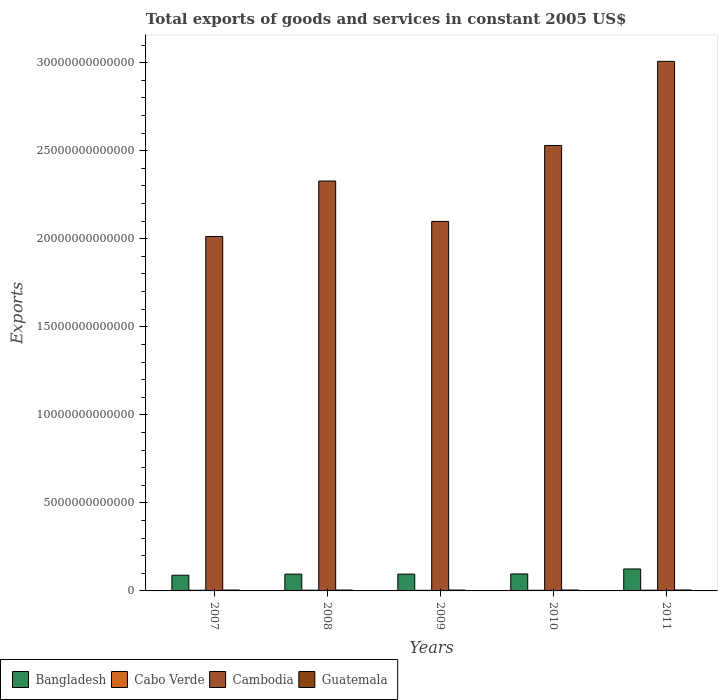How many different coloured bars are there?
Provide a short and direct response. 4. Are the number of bars on each tick of the X-axis equal?
Keep it short and to the point. Yes. How many bars are there on the 4th tick from the left?
Your response must be concise. 4. How many bars are there on the 1st tick from the right?
Offer a terse response. 4. What is the total exports of goods and services in Cambodia in 2007?
Ensure brevity in your answer.  2.01e+13. Across all years, what is the maximum total exports of goods and services in Cabo Verde?
Ensure brevity in your answer.  4.15e+1. Across all years, what is the minimum total exports of goods and services in Guatemala?
Give a very brief answer. 4.90e+1. What is the total total exports of goods and services in Cambodia in the graph?
Give a very brief answer. 1.20e+14. What is the difference between the total exports of goods and services in Bangladesh in 2007 and that in 2011?
Provide a short and direct response. -3.55e+11. What is the difference between the total exports of goods and services in Bangladesh in 2007 and the total exports of goods and services in Cabo Verde in 2009?
Provide a short and direct response. 8.57e+11. What is the average total exports of goods and services in Bangladesh per year?
Ensure brevity in your answer.  1.00e+12. In the year 2008, what is the difference between the total exports of goods and services in Guatemala and total exports of goods and services in Bangladesh?
Keep it short and to the point. -9.04e+11. In how many years, is the total exports of goods and services in Bangladesh greater than 19000000000000 US$?
Provide a short and direct response. 0. What is the ratio of the total exports of goods and services in Bangladesh in 2008 to that in 2009?
Your answer should be very brief. 1. Is the difference between the total exports of goods and services in Guatemala in 2008 and 2011 greater than the difference between the total exports of goods and services in Bangladesh in 2008 and 2011?
Provide a succinct answer. Yes. What is the difference between the highest and the second highest total exports of goods and services in Cambodia?
Offer a terse response. 4.78e+12. What is the difference between the highest and the lowest total exports of goods and services in Cambodia?
Provide a short and direct response. 9.95e+12. In how many years, is the total exports of goods and services in Cambodia greater than the average total exports of goods and services in Cambodia taken over all years?
Ensure brevity in your answer.  2. What does the 1st bar from the right in 2009 represents?
Your response must be concise. Guatemala. How many bars are there?
Provide a short and direct response. 20. What is the difference between two consecutive major ticks on the Y-axis?
Offer a very short reply. 5.00e+12. Are the values on the major ticks of Y-axis written in scientific E-notation?
Keep it short and to the point. No. Does the graph contain any zero values?
Your answer should be very brief. No. Does the graph contain grids?
Provide a succinct answer. No. Where does the legend appear in the graph?
Provide a short and direct response. Bottom left. How many legend labels are there?
Your answer should be compact. 4. What is the title of the graph?
Your response must be concise. Total exports of goods and services in constant 2005 US$. Does "Finland" appear as one of the legend labels in the graph?
Make the answer very short. No. What is the label or title of the Y-axis?
Ensure brevity in your answer.  Exports. What is the Exports of Bangladesh in 2007?
Your response must be concise. 8.91e+11. What is the Exports of Cabo Verde in 2007?
Keep it short and to the point. 3.85e+1. What is the Exports in Cambodia in 2007?
Offer a terse response. 2.01e+13. What is the Exports in Guatemala in 2007?
Make the answer very short. 5.05e+1. What is the Exports of Bangladesh in 2008?
Your answer should be compact. 9.54e+11. What is the Exports of Cabo Verde in 2008?
Your response must be concise. 4.13e+1. What is the Exports in Cambodia in 2008?
Offer a terse response. 2.33e+13. What is the Exports of Guatemala in 2008?
Provide a short and direct response. 5.04e+1. What is the Exports in Bangladesh in 2009?
Offer a very short reply. 9.55e+11. What is the Exports of Cabo Verde in 2009?
Your answer should be compact. 3.41e+1. What is the Exports in Cambodia in 2009?
Your answer should be compact. 2.10e+13. What is the Exports in Guatemala in 2009?
Keep it short and to the point. 4.90e+1. What is the Exports of Bangladesh in 2010?
Provide a succinct answer. 9.63e+11. What is the Exports in Cabo Verde in 2010?
Your response must be concise. 3.73e+1. What is the Exports in Cambodia in 2010?
Ensure brevity in your answer.  2.53e+13. What is the Exports of Guatemala in 2010?
Give a very brief answer. 5.20e+1. What is the Exports in Bangladesh in 2011?
Give a very brief answer. 1.25e+12. What is the Exports of Cabo Verde in 2011?
Offer a terse response. 4.15e+1. What is the Exports in Cambodia in 2011?
Your response must be concise. 3.01e+13. What is the Exports in Guatemala in 2011?
Your answer should be very brief. 5.36e+1. Across all years, what is the maximum Exports of Bangladesh?
Keep it short and to the point. 1.25e+12. Across all years, what is the maximum Exports in Cabo Verde?
Provide a short and direct response. 4.15e+1. Across all years, what is the maximum Exports in Cambodia?
Offer a very short reply. 3.01e+13. Across all years, what is the maximum Exports in Guatemala?
Provide a short and direct response. 5.36e+1. Across all years, what is the minimum Exports of Bangladesh?
Your answer should be very brief. 8.91e+11. Across all years, what is the minimum Exports of Cabo Verde?
Your response must be concise. 3.41e+1. Across all years, what is the minimum Exports in Cambodia?
Offer a very short reply. 2.01e+13. Across all years, what is the minimum Exports of Guatemala?
Make the answer very short. 4.90e+1. What is the total Exports in Bangladesh in the graph?
Ensure brevity in your answer.  5.01e+12. What is the total Exports in Cabo Verde in the graph?
Your answer should be compact. 1.93e+11. What is the total Exports in Cambodia in the graph?
Offer a terse response. 1.20e+14. What is the total Exports in Guatemala in the graph?
Your answer should be very brief. 2.55e+11. What is the difference between the Exports in Bangladesh in 2007 and that in 2008?
Keep it short and to the point. -6.31e+1. What is the difference between the Exports of Cabo Verde in 2007 and that in 2008?
Your answer should be very brief. -2.83e+09. What is the difference between the Exports of Cambodia in 2007 and that in 2008?
Your answer should be compact. -3.15e+12. What is the difference between the Exports in Guatemala in 2007 and that in 2008?
Offer a very short reply. 8.22e+07. What is the difference between the Exports of Bangladesh in 2007 and that in 2009?
Your response must be concise. -6.34e+1. What is the difference between the Exports in Cabo Verde in 2007 and that in 2009?
Your answer should be very brief. 4.38e+09. What is the difference between the Exports in Cambodia in 2007 and that in 2009?
Provide a succinct answer. -8.55e+11. What is the difference between the Exports in Guatemala in 2007 and that in 2009?
Provide a short and direct response. 1.42e+09. What is the difference between the Exports in Bangladesh in 2007 and that in 2010?
Offer a very short reply. -7.24e+1. What is the difference between the Exports of Cabo Verde in 2007 and that in 2010?
Your answer should be very brief. 1.20e+09. What is the difference between the Exports of Cambodia in 2007 and that in 2010?
Your answer should be compact. -5.17e+12. What is the difference between the Exports in Guatemala in 2007 and that in 2010?
Provide a short and direct response. -1.58e+09. What is the difference between the Exports of Bangladesh in 2007 and that in 2011?
Ensure brevity in your answer.  -3.55e+11. What is the difference between the Exports of Cabo Verde in 2007 and that in 2011?
Your answer should be very brief. -3.00e+09. What is the difference between the Exports in Cambodia in 2007 and that in 2011?
Keep it short and to the point. -9.95e+12. What is the difference between the Exports in Guatemala in 2007 and that in 2011?
Give a very brief answer. -3.15e+09. What is the difference between the Exports in Bangladesh in 2008 and that in 2009?
Ensure brevity in your answer.  -2.72e+08. What is the difference between the Exports in Cabo Verde in 2008 and that in 2009?
Your answer should be compact. 7.21e+09. What is the difference between the Exports in Cambodia in 2008 and that in 2009?
Offer a terse response. 2.30e+12. What is the difference between the Exports in Guatemala in 2008 and that in 2009?
Your answer should be very brief. 1.34e+09. What is the difference between the Exports of Bangladesh in 2008 and that in 2010?
Provide a short and direct response. -9.26e+09. What is the difference between the Exports in Cabo Verde in 2008 and that in 2010?
Give a very brief answer. 4.03e+09. What is the difference between the Exports in Cambodia in 2008 and that in 2010?
Keep it short and to the point. -2.02e+12. What is the difference between the Exports of Guatemala in 2008 and that in 2010?
Provide a short and direct response. -1.67e+09. What is the difference between the Exports of Bangladesh in 2008 and that in 2011?
Your answer should be very brief. -2.92e+11. What is the difference between the Exports of Cabo Verde in 2008 and that in 2011?
Your answer should be very brief. -1.64e+08. What is the difference between the Exports of Cambodia in 2008 and that in 2011?
Offer a terse response. -6.80e+12. What is the difference between the Exports of Guatemala in 2008 and that in 2011?
Offer a very short reply. -3.23e+09. What is the difference between the Exports in Bangladesh in 2009 and that in 2010?
Make the answer very short. -8.99e+09. What is the difference between the Exports of Cabo Verde in 2009 and that in 2010?
Provide a succinct answer. -3.18e+09. What is the difference between the Exports of Cambodia in 2009 and that in 2010?
Offer a very short reply. -4.31e+12. What is the difference between the Exports of Guatemala in 2009 and that in 2010?
Offer a very short reply. -3.01e+09. What is the difference between the Exports in Bangladesh in 2009 and that in 2011?
Your response must be concise. -2.92e+11. What is the difference between the Exports of Cabo Verde in 2009 and that in 2011?
Provide a short and direct response. -7.37e+09. What is the difference between the Exports of Cambodia in 2009 and that in 2011?
Provide a short and direct response. -9.09e+12. What is the difference between the Exports of Guatemala in 2009 and that in 2011?
Your response must be concise. -4.57e+09. What is the difference between the Exports of Bangladesh in 2010 and that in 2011?
Ensure brevity in your answer.  -2.83e+11. What is the difference between the Exports in Cabo Verde in 2010 and that in 2011?
Provide a succinct answer. -4.19e+09. What is the difference between the Exports in Cambodia in 2010 and that in 2011?
Give a very brief answer. -4.78e+12. What is the difference between the Exports of Guatemala in 2010 and that in 2011?
Ensure brevity in your answer.  -1.57e+09. What is the difference between the Exports in Bangladesh in 2007 and the Exports in Cabo Verde in 2008?
Your answer should be compact. 8.50e+11. What is the difference between the Exports of Bangladesh in 2007 and the Exports of Cambodia in 2008?
Offer a very short reply. -2.24e+13. What is the difference between the Exports in Bangladesh in 2007 and the Exports in Guatemala in 2008?
Your answer should be compact. 8.41e+11. What is the difference between the Exports in Cabo Verde in 2007 and the Exports in Cambodia in 2008?
Make the answer very short. -2.32e+13. What is the difference between the Exports of Cabo Verde in 2007 and the Exports of Guatemala in 2008?
Keep it short and to the point. -1.19e+1. What is the difference between the Exports of Cambodia in 2007 and the Exports of Guatemala in 2008?
Give a very brief answer. 2.01e+13. What is the difference between the Exports in Bangladesh in 2007 and the Exports in Cabo Verde in 2009?
Ensure brevity in your answer.  8.57e+11. What is the difference between the Exports in Bangladesh in 2007 and the Exports in Cambodia in 2009?
Your answer should be compact. -2.01e+13. What is the difference between the Exports in Bangladesh in 2007 and the Exports in Guatemala in 2009?
Give a very brief answer. 8.42e+11. What is the difference between the Exports in Cabo Verde in 2007 and the Exports in Cambodia in 2009?
Offer a terse response. -2.09e+13. What is the difference between the Exports of Cabo Verde in 2007 and the Exports of Guatemala in 2009?
Provide a short and direct response. -1.06e+1. What is the difference between the Exports in Cambodia in 2007 and the Exports in Guatemala in 2009?
Your answer should be very brief. 2.01e+13. What is the difference between the Exports of Bangladesh in 2007 and the Exports of Cabo Verde in 2010?
Offer a terse response. 8.54e+11. What is the difference between the Exports in Bangladesh in 2007 and the Exports in Cambodia in 2010?
Provide a succinct answer. -2.44e+13. What is the difference between the Exports in Bangladesh in 2007 and the Exports in Guatemala in 2010?
Make the answer very short. 8.39e+11. What is the difference between the Exports in Cabo Verde in 2007 and the Exports in Cambodia in 2010?
Your response must be concise. -2.53e+13. What is the difference between the Exports in Cabo Verde in 2007 and the Exports in Guatemala in 2010?
Provide a short and direct response. -1.36e+1. What is the difference between the Exports in Cambodia in 2007 and the Exports in Guatemala in 2010?
Your answer should be very brief. 2.01e+13. What is the difference between the Exports in Bangladesh in 2007 and the Exports in Cabo Verde in 2011?
Offer a very short reply. 8.50e+11. What is the difference between the Exports in Bangladesh in 2007 and the Exports in Cambodia in 2011?
Your answer should be compact. -2.92e+13. What is the difference between the Exports in Bangladesh in 2007 and the Exports in Guatemala in 2011?
Provide a succinct answer. 8.38e+11. What is the difference between the Exports of Cabo Verde in 2007 and the Exports of Cambodia in 2011?
Give a very brief answer. -3.00e+13. What is the difference between the Exports of Cabo Verde in 2007 and the Exports of Guatemala in 2011?
Your answer should be very brief. -1.51e+1. What is the difference between the Exports in Cambodia in 2007 and the Exports in Guatemala in 2011?
Make the answer very short. 2.01e+13. What is the difference between the Exports of Bangladesh in 2008 and the Exports of Cabo Verde in 2009?
Ensure brevity in your answer.  9.20e+11. What is the difference between the Exports in Bangladesh in 2008 and the Exports in Cambodia in 2009?
Make the answer very short. -2.00e+13. What is the difference between the Exports of Bangladesh in 2008 and the Exports of Guatemala in 2009?
Make the answer very short. 9.05e+11. What is the difference between the Exports of Cabo Verde in 2008 and the Exports of Cambodia in 2009?
Ensure brevity in your answer.  -2.09e+13. What is the difference between the Exports of Cabo Verde in 2008 and the Exports of Guatemala in 2009?
Make the answer very short. -7.73e+09. What is the difference between the Exports in Cambodia in 2008 and the Exports in Guatemala in 2009?
Provide a short and direct response. 2.32e+13. What is the difference between the Exports in Bangladesh in 2008 and the Exports in Cabo Verde in 2010?
Offer a very short reply. 9.17e+11. What is the difference between the Exports in Bangladesh in 2008 and the Exports in Cambodia in 2010?
Your answer should be very brief. -2.43e+13. What is the difference between the Exports in Bangladesh in 2008 and the Exports in Guatemala in 2010?
Provide a succinct answer. 9.02e+11. What is the difference between the Exports in Cabo Verde in 2008 and the Exports in Cambodia in 2010?
Keep it short and to the point. -2.53e+13. What is the difference between the Exports of Cabo Verde in 2008 and the Exports of Guatemala in 2010?
Provide a short and direct response. -1.07e+1. What is the difference between the Exports of Cambodia in 2008 and the Exports of Guatemala in 2010?
Provide a short and direct response. 2.32e+13. What is the difference between the Exports in Bangladesh in 2008 and the Exports in Cabo Verde in 2011?
Provide a short and direct response. 9.13e+11. What is the difference between the Exports of Bangladesh in 2008 and the Exports of Cambodia in 2011?
Offer a very short reply. -2.91e+13. What is the difference between the Exports of Bangladesh in 2008 and the Exports of Guatemala in 2011?
Provide a short and direct response. 9.01e+11. What is the difference between the Exports of Cabo Verde in 2008 and the Exports of Cambodia in 2011?
Your answer should be compact. -3.00e+13. What is the difference between the Exports of Cabo Verde in 2008 and the Exports of Guatemala in 2011?
Your answer should be very brief. -1.23e+1. What is the difference between the Exports in Cambodia in 2008 and the Exports in Guatemala in 2011?
Make the answer very short. 2.32e+13. What is the difference between the Exports of Bangladesh in 2009 and the Exports of Cabo Verde in 2010?
Your response must be concise. 9.17e+11. What is the difference between the Exports in Bangladesh in 2009 and the Exports in Cambodia in 2010?
Your answer should be compact. -2.43e+13. What is the difference between the Exports of Bangladesh in 2009 and the Exports of Guatemala in 2010?
Offer a terse response. 9.02e+11. What is the difference between the Exports in Cabo Verde in 2009 and the Exports in Cambodia in 2010?
Offer a very short reply. -2.53e+13. What is the difference between the Exports in Cabo Verde in 2009 and the Exports in Guatemala in 2010?
Your answer should be compact. -1.79e+1. What is the difference between the Exports of Cambodia in 2009 and the Exports of Guatemala in 2010?
Provide a short and direct response. 2.09e+13. What is the difference between the Exports of Bangladesh in 2009 and the Exports of Cabo Verde in 2011?
Ensure brevity in your answer.  9.13e+11. What is the difference between the Exports in Bangladesh in 2009 and the Exports in Cambodia in 2011?
Give a very brief answer. -2.91e+13. What is the difference between the Exports of Bangladesh in 2009 and the Exports of Guatemala in 2011?
Keep it short and to the point. 9.01e+11. What is the difference between the Exports of Cabo Verde in 2009 and the Exports of Cambodia in 2011?
Your answer should be compact. -3.00e+13. What is the difference between the Exports of Cabo Verde in 2009 and the Exports of Guatemala in 2011?
Provide a succinct answer. -1.95e+1. What is the difference between the Exports of Cambodia in 2009 and the Exports of Guatemala in 2011?
Your answer should be very brief. 2.09e+13. What is the difference between the Exports in Bangladesh in 2010 and the Exports in Cabo Verde in 2011?
Make the answer very short. 9.22e+11. What is the difference between the Exports in Bangladesh in 2010 and the Exports in Cambodia in 2011?
Give a very brief answer. -2.91e+13. What is the difference between the Exports in Bangladesh in 2010 and the Exports in Guatemala in 2011?
Your answer should be compact. 9.10e+11. What is the difference between the Exports of Cabo Verde in 2010 and the Exports of Cambodia in 2011?
Ensure brevity in your answer.  -3.00e+13. What is the difference between the Exports of Cabo Verde in 2010 and the Exports of Guatemala in 2011?
Offer a very short reply. -1.63e+1. What is the difference between the Exports in Cambodia in 2010 and the Exports in Guatemala in 2011?
Your answer should be very brief. 2.52e+13. What is the average Exports of Bangladesh per year?
Provide a short and direct response. 1.00e+12. What is the average Exports in Cabo Verde per year?
Make the answer very short. 3.85e+1. What is the average Exports of Cambodia per year?
Make the answer very short. 2.40e+13. What is the average Exports in Guatemala per year?
Offer a very short reply. 5.11e+1. In the year 2007, what is the difference between the Exports of Bangladesh and Exports of Cabo Verde?
Keep it short and to the point. 8.53e+11. In the year 2007, what is the difference between the Exports of Bangladesh and Exports of Cambodia?
Your answer should be compact. -1.92e+13. In the year 2007, what is the difference between the Exports in Bangladesh and Exports in Guatemala?
Your answer should be compact. 8.41e+11. In the year 2007, what is the difference between the Exports in Cabo Verde and Exports in Cambodia?
Make the answer very short. -2.01e+13. In the year 2007, what is the difference between the Exports in Cabo Verde and Exports in Guatemala?
Give a very brief answer. -1.20e+1. In the year 2007, what is the difference between the Exports in Cambodia and Exports in Guatemala?
Give a very brief answer. 2.01e+13. In the year 2008, what is the difference between the Exports in Bangladesh and Exports in Cabo Verde?
Offer a very short reply. 9.13e+11. In the year 2008, what is the difference between the Exports of Bangladesh and Exports of Cambodia?
Make the answer very short. -2.23e+13. In the year 2008, what is the difference between the Exports of Bangladesh and Exports of Guatemala?
Ensure brevity in your answer.  9.04e+11. In the year 2008, what is the difference between the Exports in Cabo Verde and Exports in Cambodia?
Make the answer very short. -2.32e+13. In the year 2008, what is the difference between the Exports of Cabo Verde and Exports of Guatemala?
Make the answer very short. -9.07e+09. In the year 2008, what is the difference between the Exports in Cambodia and Exports in Guatemala?
Offer a very short reply. 2.32e+13. In the year 2009, what is the difference between the Exports of Bangladesh and Exports of Cabo Verde?
Offer a terse response. 9.20e+11. In the year 2009, what is the difference between the Exports of Bangladesh and Exports of Cambodia?
Offer a terse response. -2.00e+13. In the year 2009, what is the difference between the Exports in Bangladesh and Exports in Guatemala?
Ensure brevity in your answer.  9.05e+11. In the year 2009, what is the difference between the Exports in Cabo Verde and Exports in Cambodia?
Offer a very short reply. -2.09e+13. In the year 2009, what is the difference between the Exports of Cabo Verde and Exports of Guatemala?
Your answer should be compact. -1.49e+1. In the year 2009, what is the difference between the Exports in Cambodia and Exports in Guatemala?
Keep it short and to the point. 2.09e+13. In the year 2010, what is the difference between the Exports of Bangladesh and Exports of Cabo Verde?
Give a very brief answer. 9.26e+11. In the year 2010, what is the difference between the Exports in Bangladesh and Exports in Cambodia?
Provide a succinct answer. -2.43e+13. In the year 2010, what is the difference between the Exports in Bangladesh and Exports in Guatemala?
Give a very brief answer. 9.11e+11. In the year 2010, what is the difference between the Exports of Cabo Verde and Exports of Cambodia?
Keep it short and to the point. -2.53e+13. In the year 2010, what is the difference between the Exports of Cabo Verde and Exports of Guatemala?
Offer a very short reply. -1.48e+1. In the year 2010, what is the difference between the Exports in Cambodia and Exports in Guatemala?
Keep it short and to the point. 2.52e+13. In the year 2011, what is the difference between the Exports of Bangladesh and Exports of Cabo Verde?
Offer a very short reply. 1.20e+12. In the year 2011, what is the difference between the Exports of Bangladesh and Exports of Cambodia?
Make the answer very short. -2.88e+13. In the year 2011, what is the difference between the Exports of Bangladesh and Exports of Guatemala?
Keep it short and to the point. 1.19e+12. In the year 2011, what is the difference between the Exports of Cabo Verde and Exports of Cambodia?
Give a very brief answer. -3.00e+13. In the year 2011, what is the difference between the Exports in Cabo Verde and Exports in Guatemala?
Offer a terse response. -1.21e+1. In the year 2011, what is the difference between the Exports in Cambodia and Exports in Guatemala?
Your response must be concise. 3.00e+13. What is the ratio of the Exports in Bangladesh in 2007 to that in 2008?
Provide a succinct answer. 0.93. What is the ratio of the Exports of Cabo Verde in 2007 to that in 2008?
Keep it short and to the point. 0.93. What is the ratio of the Exports in Cambodia in 2007 to that in 2008?
Keep it short and to the point. 0.86. What is the ratio of the Exports of Bangladesh in 2007 to that in 2009?
Make the answer very short. 0.93. What is the ratio of the Exports of Cabo Verde in 2007 to that in 2009?
Provide a short and direct response. 1.13. What is the ratio of the Exports in Cambodia in 2007 to that in 2009?
Your answer should be compact. 0.96. What is the ratio of the Exports of Bangladesh in 2007 to that in 2010?
Give a very brief answer. 0.92. What is the ratio of the Exports in Cabo Verde in 2007 to that in 2010?
Offer a very short reply. 1.03. What is the ratio of the Exports in Cambodia in 2007 to that in 2010?
Make the answer very short. 0.8. What is the ratio of the Exports in Guatemala in 2007 to that in 2010?
Make the answer very short. 0.97. What is the ratio of the Exports in Bangladesh in 2007 to that in 2011?
Keep it short and to the point. 0.72. What is the ratio of the Exports in Cabo Verde in 2007 to that in 2011?
Make the answer very short. 0.93. What is the ratio of the Exports of Cambodia in 2007 to that in 2011?
Provide a succinct answer. 0.67. What is the ratio of the Exports in Bangladesh in 2008 to that in 2009?
Ensure brevity in your answer.  1. What is the ratio of the Exports in Cabo Verde in 2008 to that in 2009?
Your response must be concise. 1.21. What is the ratio of the Exports in Cambodia in 2008 to that in 2009?
Your answer should be compact. 1.11. What is the ratio of the Exports of Guatemala in 2008 to that in 2009?
Your response must be concise. 1.03. What is the ratio of the Exports of Cabo Verde in 2008 to that in 2010?
Your answer should be compact. 1.11. What is the ratio of the Exports in Cambodia in 2008 to that in 2010?
Ensure brevity in your answer.  0.92. What is the ratio of the Exports in Bangladesh in 2008 to that in 2011?
Provide a succinct answer. 0.77. What is the ratio of the Exports of Cabo Verde in 2008 to that in 2011?
Provide a short and direct response. 1. What is the ratio of the Exports of Cambodia in 2008 to that in 2011?
Offer a very short reply. 0.77. What is the ratio of the Exports of Guatemala in 2008 to that in 2011?
Provide a short and direct response. 0.94. What is the ratio of the Exports in Bangladesh in 2009 to that in 2010?
Give a very brief answer. 0.99. What is the ratio of the Exports in Cabo Verde in 2009 to that in 2010?
Provide a succinct answer. 0.91. What is the ratio of the Exports in Cambodia in 2009 to that in 2010?
Your answer should be very brief. 0.83. What is the ratio of the Exports of Guatemala in 2009 to that in 2010?
Your response must be concise. 0.94. What is the ratio of the Exports of Bangladesh in 2009 to that in 2011?
Provide a short and direct response. 0.77. What is the ratio of the Exports in Cabo Verde in 2009 to that in 2011?
Ensure brevity in your answer.  0.82. What is the ratio of the Exports in Cambodia in 2009 to that in 2011?
Offer a very short reply. 0.7. What is the ratio of the Exports of Guatemala in 2009 to that in 2011?
Give a very brief answer. 0.91. What is the ratio of the Exports of Bangladesh in 2010 to that in 2011?
Keep it short and to the point. 0.77. What is the ratio of the Exports in Cabo Verde in 2010 to that in 2011?
Make the answer very short. 0.9. What is the ratio of the Exports of Cambodia in 2010 to that in 2011?
Give a very brief answer. 0.84. What is the ratio of the Exports of Guatemala in 2010 to that in 2011?
Offer a terse response. 0.97. What is the difference between the highest and the second highest Exports in Bangladesh?
Provide a succinct answer. 2.83e+11. What is the difference between the highest and the second highest Exports of Cabo Verde?
Provide a short and direct response. 1.64e+08. What is the difference between the highest and the second highest Exports of Cambodia?
Make the answer very short. 4.78e+12. What is the difference between the highest and the second highest Exports in Guatemala?
Provide a succinct answer. 1.57e+09. What is the difference between the highest and the lowest Exports of Bangladesh?
Give a very brief answer. 3.55e+11. What is the difference between the highest and the lowest Exports of Cabo Verde?
Your response must be concise. 7.37e+09. What is the difference between the highest and the lowest Exports of Cambodia?
Your response must be concise. 9.95e+12. What is the difference between the highest and the lowest Exports in Guatemala?
Provide a short and direct response. 4.57e+09. 